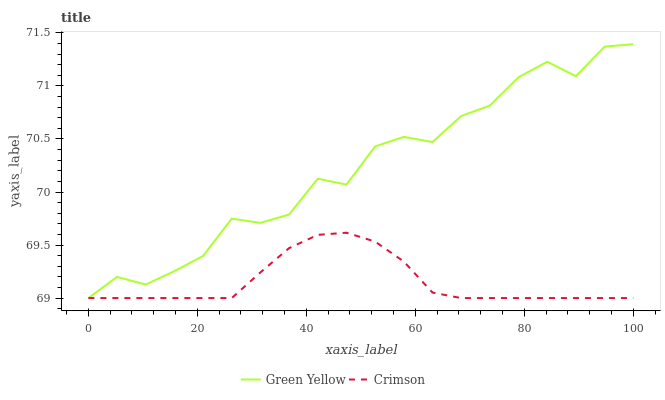Does Crimson have the minimum area under the curve?
Answer yes or no. Yes. Does Green Yellow have the maximum area under the curve?
Answer yes or no. Yes. Does Green Yellow have the minimum area under the curve?
Answer yes or no. No. Is Crimson the smoothest?
Answer yes or no. Yes. Is Green Yellow the roughest?
Answer yes or no. Yes. Is Green Yellow the smoothest?
Answer yes or no. No. Does Green Yellow have the highest value?
Answer yes or no. Yes. Does Green Yellow intersect Crimson?
Answer yes or no. Yes. Is Green Yellow less than Crimson?
Answer yes or no. No. Is Green Yellow greater than Crimson?
Answer yes or no. No. 